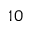Convert formula to latex. <formula><loc_0><loc_0><loc_500><loc_500>\, 1 0</formula> 